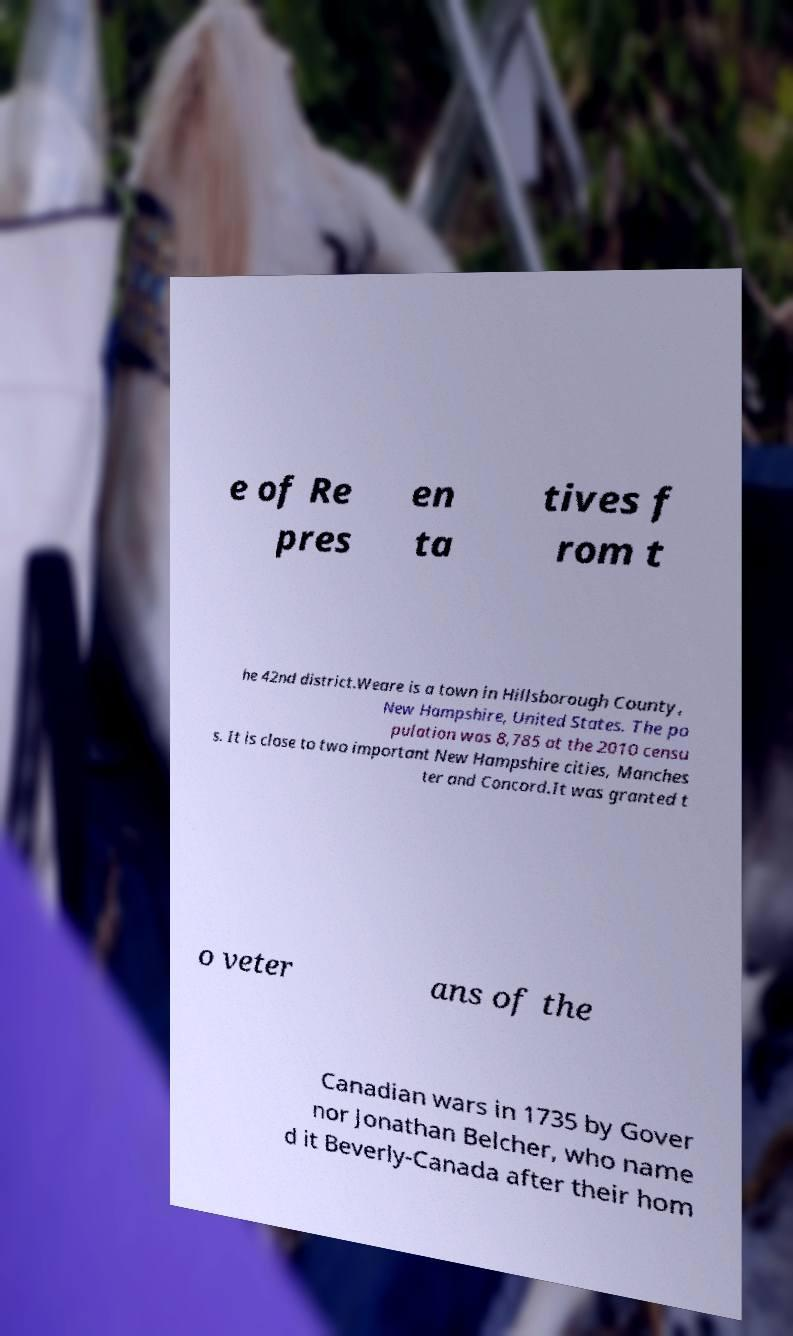Can you read and provide the text displayed in the image?This photo seems to have some interesting text. Can you extract and type it out for me? e of Re pres en ta tives f rom t he 42nd district.Weare is a town in Hillsborough County, New Hampshire, United States. The po pulation was 8,785 at the 2010 censu s. It is close to two important New Hampshire cities, Manches ter and Concord.It was granted t o veter ans of the Canadian wars in 1735 by Gover nor Jonathan Belcher, who name d it Beverly-Canada after their hom 